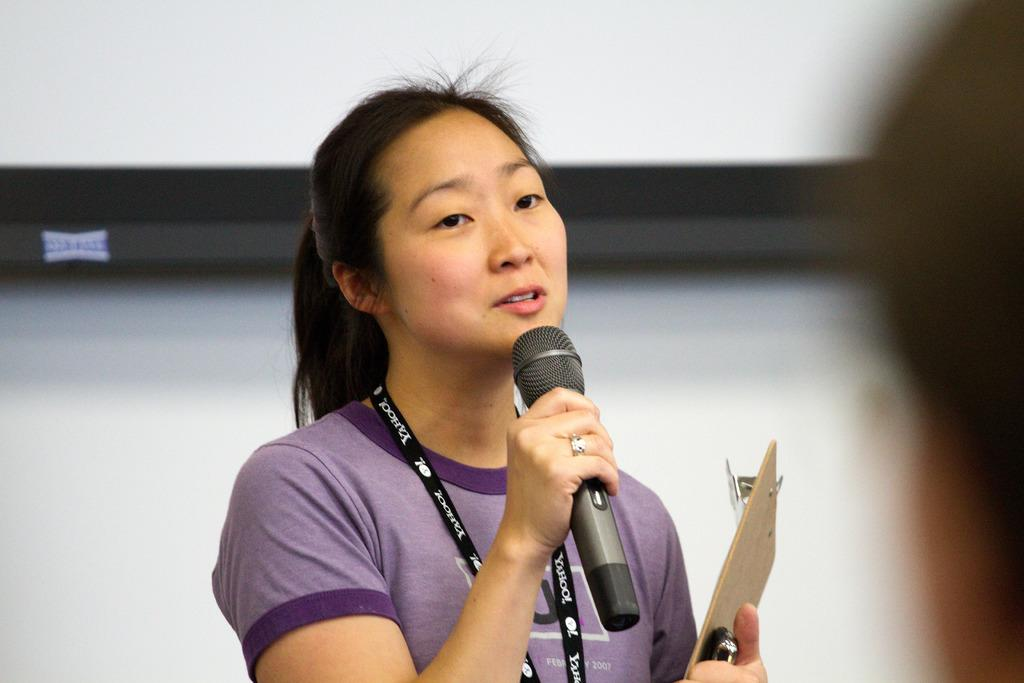Who is the main subject in the image? There is a lady in the image. What is the lady wearing? The lady is wearing a violet dress. Can you describe any additional accessories the lady is wearing? The lady is wearing a tag. What is the lady holding in her hands? The lady is holding a microphone and a writing pad. What is the lady doing in the image? The lady is speaking. What type of jeans is the lady wearing in the image? The lady is not wearing jeans in the image; she is wearing a violet dress. What kind of test is the lady conducting in the image? There is no test being conducted in the image; the lady is speaking and holding a microphone and a writing pad. 